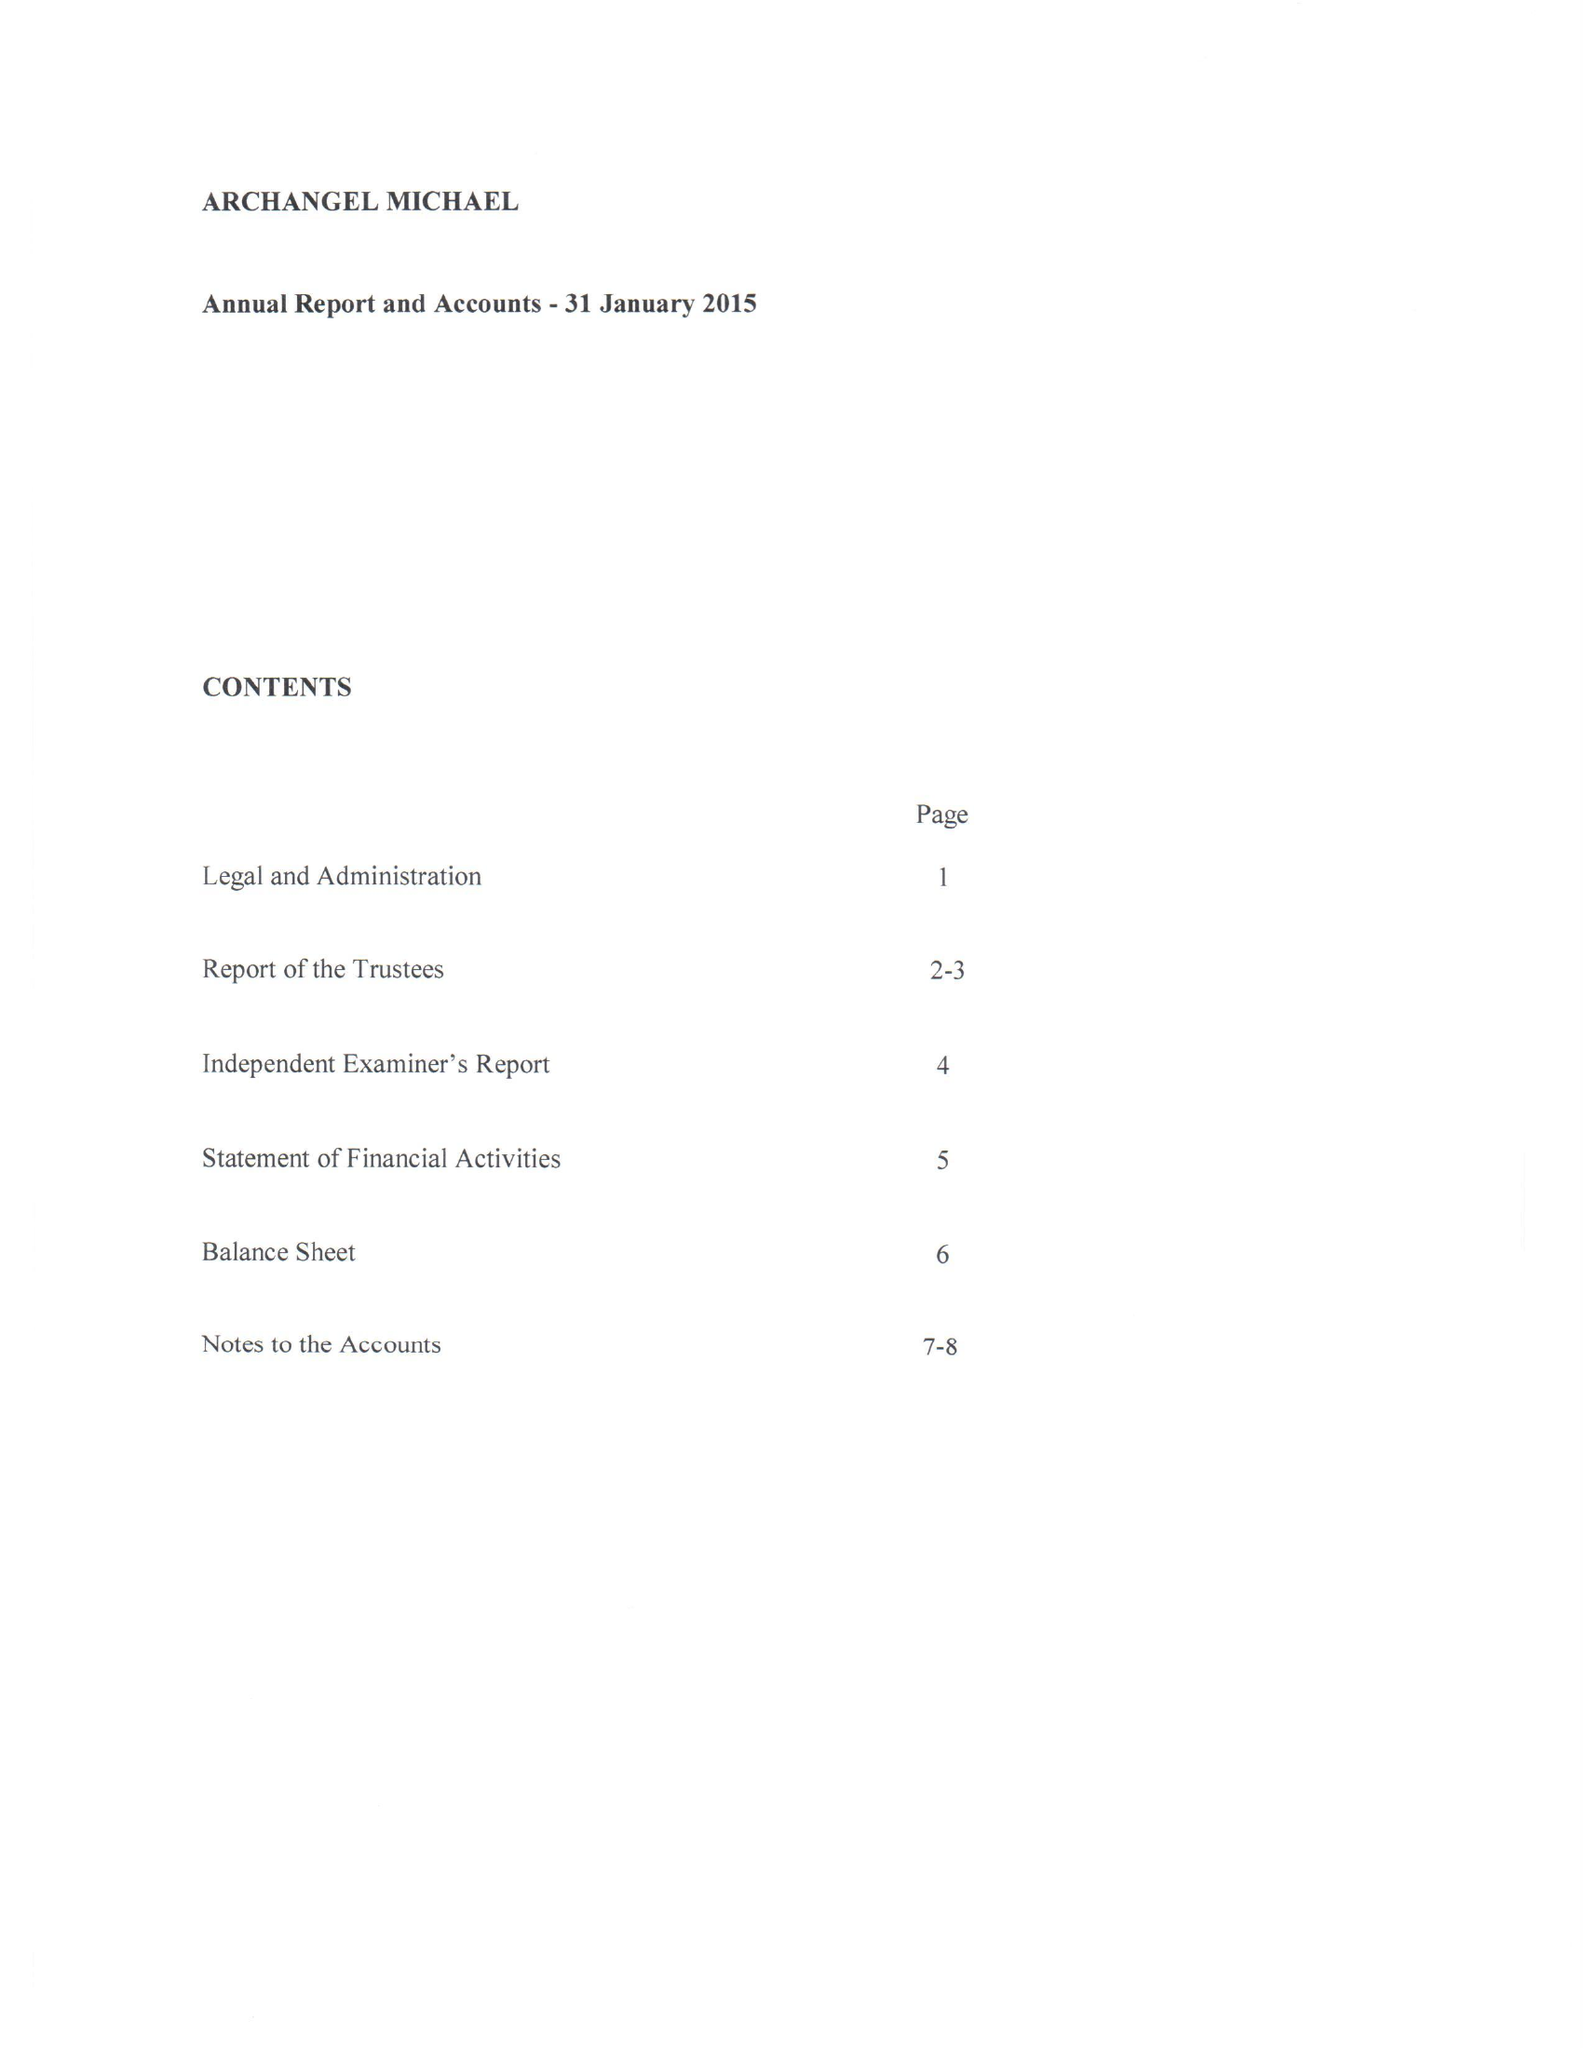What is the value for the address__street_line?
Answer the question using a single word or phrase. 10 BROOMWOOD ROAD 